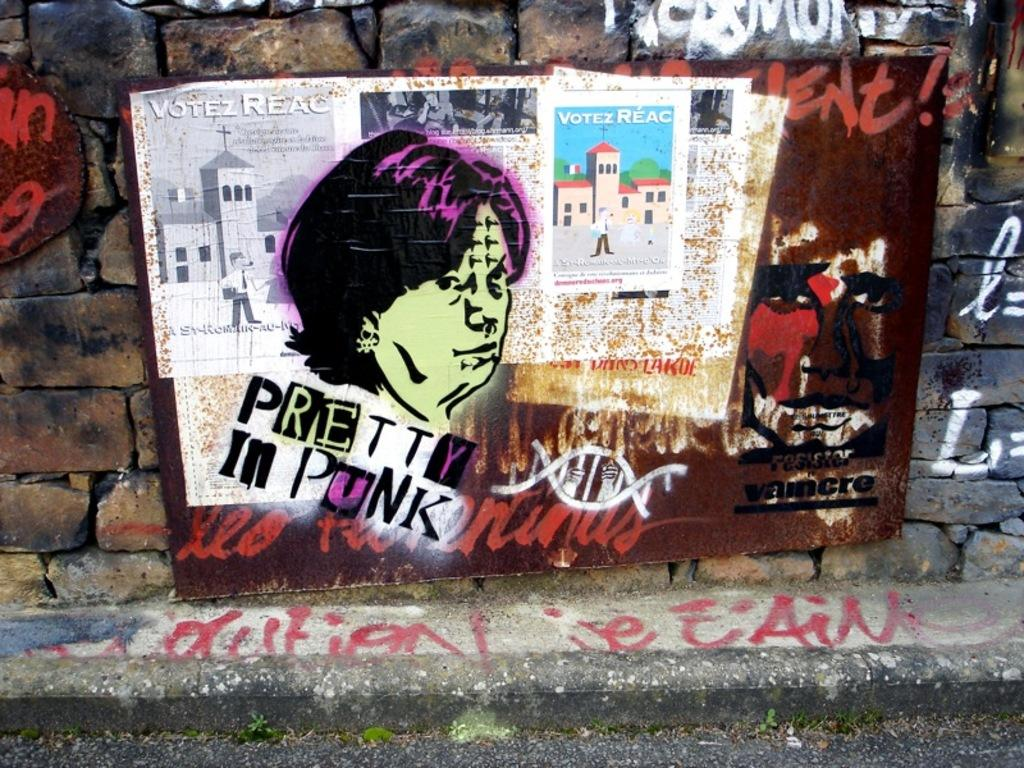<image>
Render a clear and concise summary of the photo. A brick wall with drawings and the words pretty in punk written on it. 